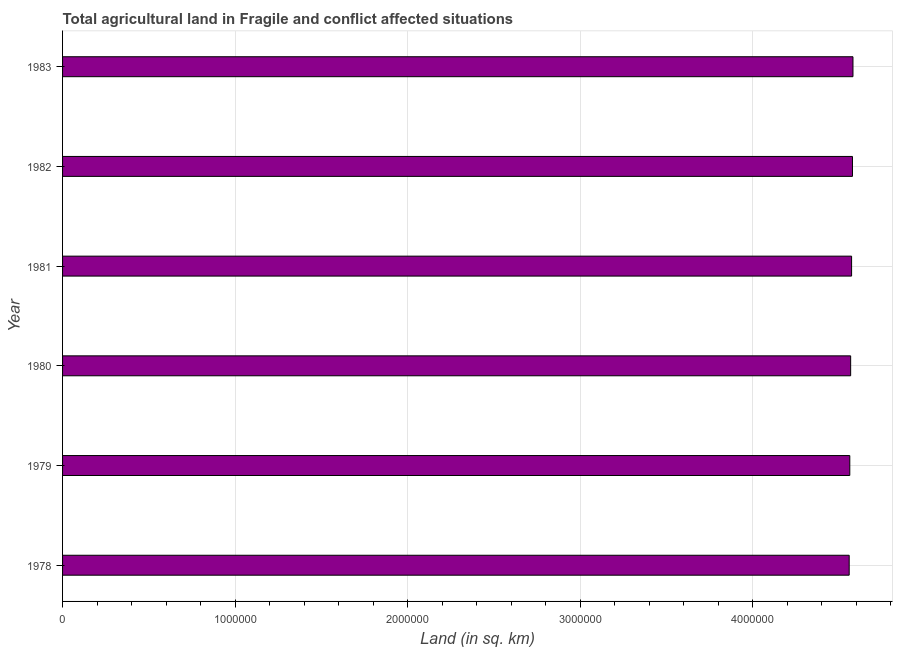Does the graph contain any zero values?
Offer a very short reply. No. Does the graph contain grids?
Your answer should be compact. Yes. What is the title of the graph?
Your answer should be very brief. Total agricultural land in Fragile and conflict affected situations. What is the label or title of the X-axis?
Keep it short and to the point. Land (in sq. km). What is the label or title of the Y-axis?
Keep it short and to the point. Year. What is the agricultural land in 1979?
Your answer should be very brief. 4.56e+06. Across all years, what is the maximum agricultural land?
Provide a succinct answer. 4.58e+06. Across all years, what is the minimum agricultural land?
Offer a terse response. 4.56e+06. In which year was the agricultural land maximum?
Offer a terse response. 1983. In which year was the agricultural land minimum?
Ensure brevity in your answer.  1978. What is the sum of the agricultural land?
Make the answer very short. 2.74e+07. What is the difference between the agricultural land in 1982 and 1983?
Keep it short and to the point. -2920. What is the average agricultural land per year?
Keep it short and to the point. 4.57e+06. What is the median agricultural land?
Your answer should be compact. 4.57e+06. Is the agricultural land in 1982 less than that in 1983?
Provide a short and direct response. Yes. Is the difference between the agricultural land in 1980 and 1982 greater than the difference between any two years?
Offer a very short reply. No. What is the difference between the highest and the second highest agricultural land?
Give a very brief answer. 2920. What is the difference between the highest and the lowest agricultural land?
Give a very brief answer. 2.19e+04. How many bars are there?
Provide a succinct answer. 6. Are all the bars in the graph horizontal?
Your answer should be compact. Yes. What is the difference between two consecutive major ticks on the X-axis?
Give a very brief answer. 1.00e+06. Are the values on the major ticks of X-axis written in scientific E-notation?
Provide a short and direct response. No. What is the Land (in sq. km) in 1978?
Offer a terse response. 4.56e+06. What is the Land (in sq. km) in 1979?
Offer a terse response. 4.56e+06. What is the Land (in sq. km) in 1980?
Give a very brief answer. 4.57e+06. What is the Land (in sq. km) of 1981?
Your answer should be compact. 4.57e+06. What is the Land (in sq. km) in 1982?
Ensure brevity in your answer.  4.58e+06. What is the Land (in sq. km) in 1983?
Provide a succinct answer. 4.58e+06. What is the difference between the Land (in sq. km) in 1978 and 1979?
Make the answer very short. -3470. What is the difference between the Land (in sq. km) in 1978 and 1980?
Your answer should be compact. -8480. What is the difference between the Land (in sq. km) in 1978 and 1981?
Ensure brevity in your answer.  -1.39e+04. What is the difference between the Land (in sq. km) in 1978 and 1982?
Keep it short and to the point. -1.90e+04. What is the difference between the Land (in sq. km) in 1978 and 1983?
Provide a succinct answer. -2.19e+04. What is the difference between the Land (in sq. km) in 1979 and 1980?
Give a very brief answer. -5010. What is the difference between the Land (in sq. km) in 1979 and 1981?
Make the answer very short. -1.04e+04. What is the difference between the Land (in sq. km) in 1979 and 1982?
Offer a terse response. -1.55e+04. What is the difference between the Land (in sq. km) in 1979 and 1983?
Offer a very short reply. -1.84e+04. What is the difference between the Land (in sq. km) in 1980 and 1981?
Your answer should be very brief. -5380. What is the difference between the Land (in sq. km) in 1980 and 1982?
Offer a very short reply. -1.05e+04. What is the difference between the Land (in sq. km) in 1980 and 1983?
Make the answer very short. -1.34e+04. What is the difference between the Land (in sq. km) in 1981 and 1982?
Provide a short and direct response. -5110. What is the difference between the Land (in sq. km) in 1981 and 1983?
Your answer should be compact. -8030. What is the difference between the Land (in sq. km) in 1982 and 1983?
Your answer should be compact. -2920. What is the ratio of the Land (in sq. km) in 1978 to that in 1980?
Provide a short and direct response. 1. What is the ratio of the Land (in sq. km) in 1978 to that in 1981?
Your answer should be compact. 1. What is the ratio of the Land (in sq. km) in 1978 to that in 1982?
Ensure brevity in your answer.  1. What is the ratio of the Land (in sq. km) in 1979 to that in 1982?
Ensure brevity in your answer.  1. What is the ratio of the Land (in sq. km) in 1980 to that in 1982?
Your response must be concise. 1. What is the ratio of the Land (in sq. km) in 1981 to that in 1982?
Your answer should be compact. 1. 